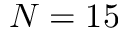Convert formula to latex. <formula><loc_0><loc_0><loc_500><loc_500>N = 1 5</formula> 